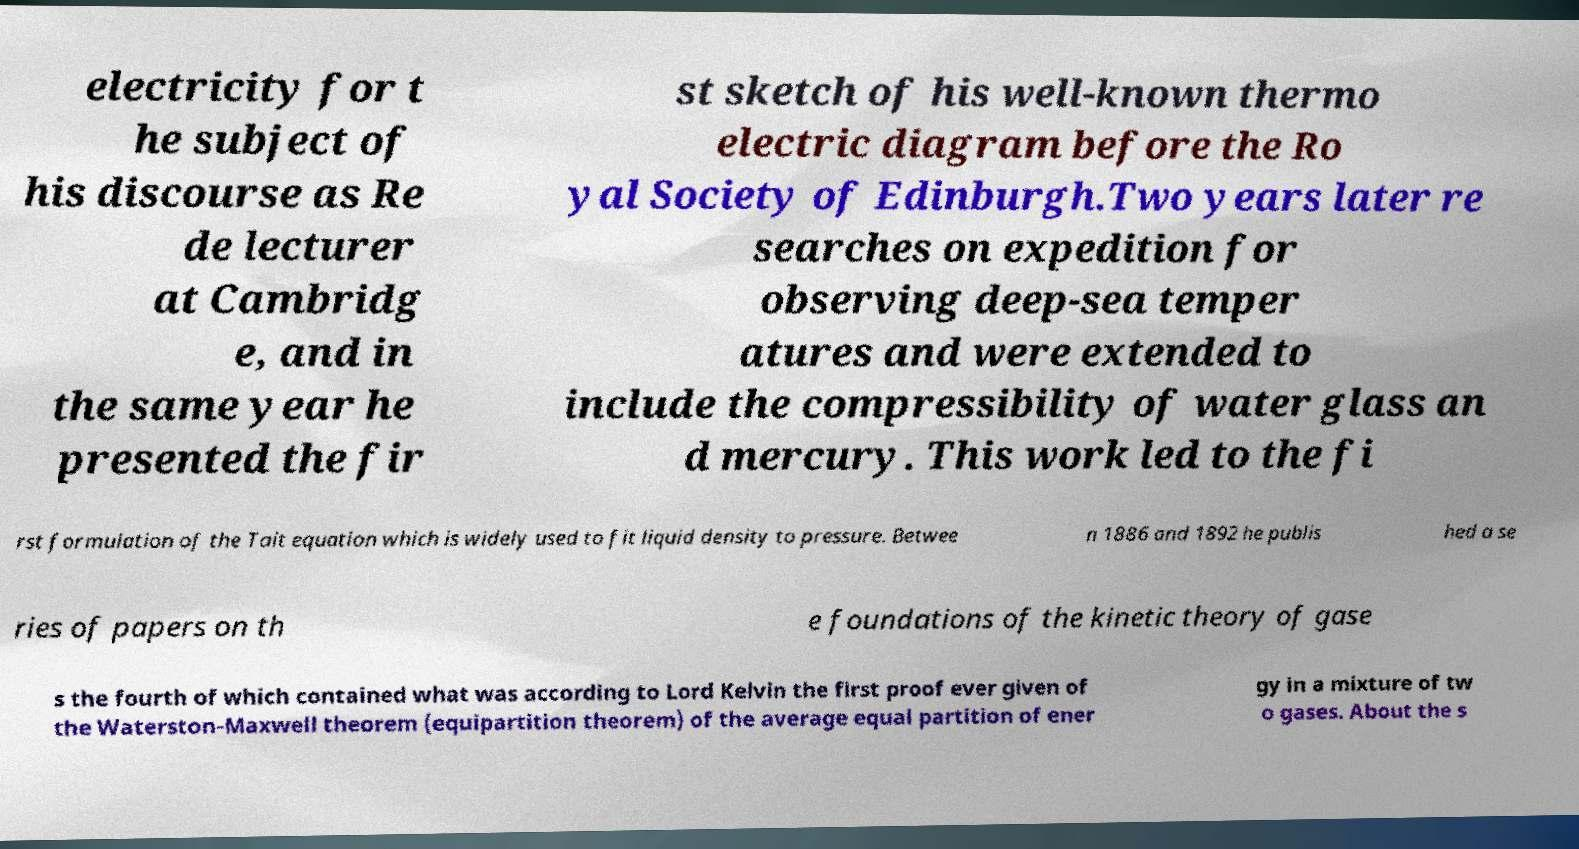Please identify and transcribe the text found in this image. electricity for t he subject of his discourse as Re de lecturer at Cambridg e, and in the same year he presented the fir st sketch of his well-known thermo electric diagram before the Ro yal Society of Edinburgh.Two years later re searches on expedition for observing deep-sea temper atures and were extended to include the compressibility of water glass an d mercury. This work led to the fi rst formulation of the Tait equation which is widely used to fit liquid density to pressure. Betwee n 1886 and 1892 he publis hed a se ries of papers on th e foundations of the kinetic theory of gase s the fourth of which contained what was according to Lord Kelvin the first proof ever given of the Waterston-Maxwell theorem (equipartition theorem) of the average equal partition of ener gy in a mixture of tw o gases. About the s 